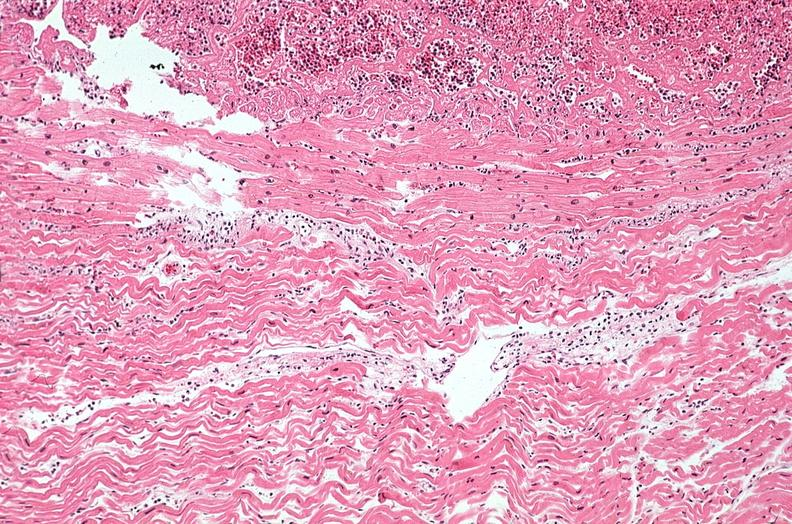where is this from?
Answer the question using a single word or phrase. Heart 